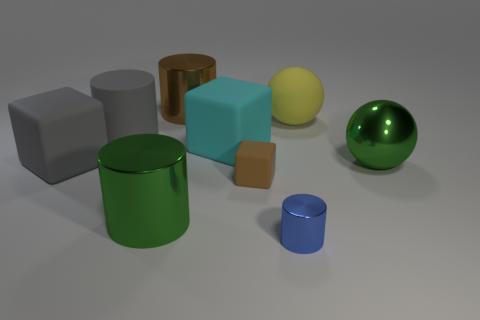Is there any other thing that is the same shape as the yellow matte thing?
Offer a terse response. Yes. What is the shape of the big gray thing that is made of the same material as the gray cube?
Keep it short and to the point. Cylinder. Are there the same number of shiny cylinders that are behind the small metallic thing and large gray things?
Give a very brief answer. Yes. Are the big green thing to the right of the yellow matte object and the cyan object that is on the left side of the blue cylinder made of the same material?
Ensure brevity in your answer.  No. There is a gray object that is behind the large rubber cube that is right of the large brown object; what is its shape?
Your response must be concise. Cylinder. What is the color of the other small cylinder that is made of the same material as the green cylinder?
Your response must be concise. Blue. There is a gray thing that is the same size as the gray cylinder; what is its shape?
Offer a very short reply. Cube. The blue thing has what size?
Your response must be concise. Small. Does the green object that is right of the matte ball have the same size as the brown object in front of the large rubber cylinder?
Offer a terse response. No. There is a sphere behind the green object that is to the right of the small matte cube; what is its color?
Provide a short and direct response. Yellow. 